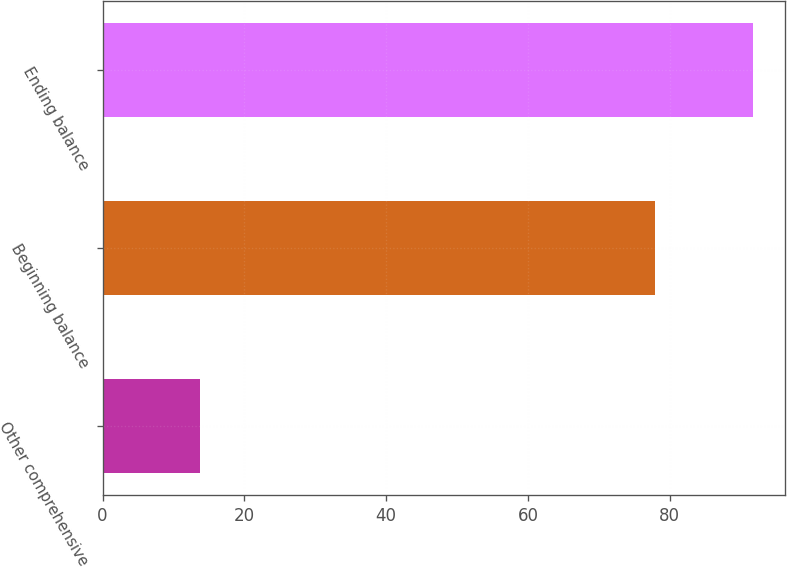<chart> <loc_0><loc_0><loc_500><loc_500><bar_chart><fcel>Other comprehensive<fcel>Beginning balance<fcel>Ending balance<nl><fcel>13.8<fcel>77.9<fcel>91.7<nl></chart> 